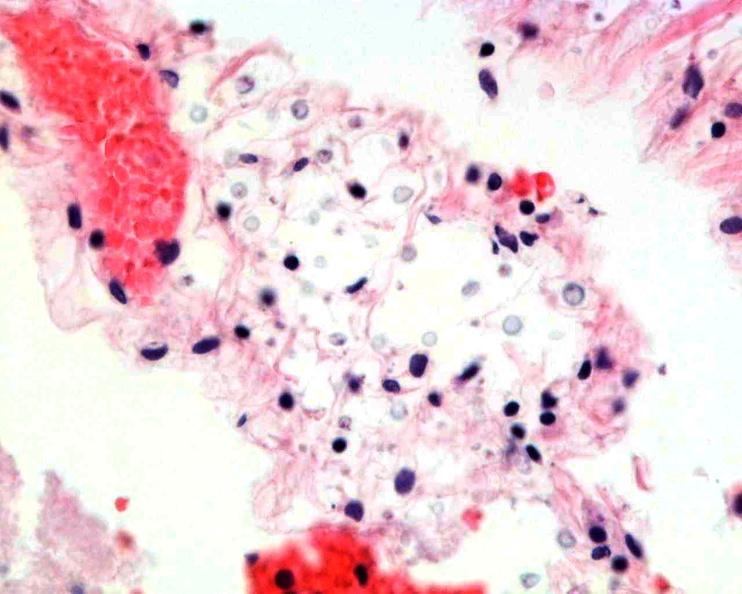s nervous present?
Answer the question using a single word or phrase. Yes 